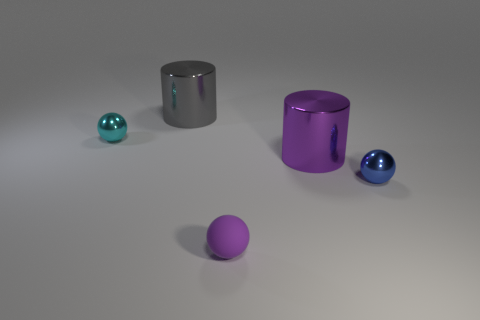Add 4 small spheres. How many objects exist? 9 Subtract all cylinders. How many objects are left? 3 Subtract all matte objects. Subtract all rubber balls. How many objects are left? 3 Add 3 large metal cylinders. How many large metal cylinders are left? 5 Add 2 big cyan metallic objects. How many big cyan metallic objects exist? 2 Subtract 0 yellow balls. How many objects are left? 5 